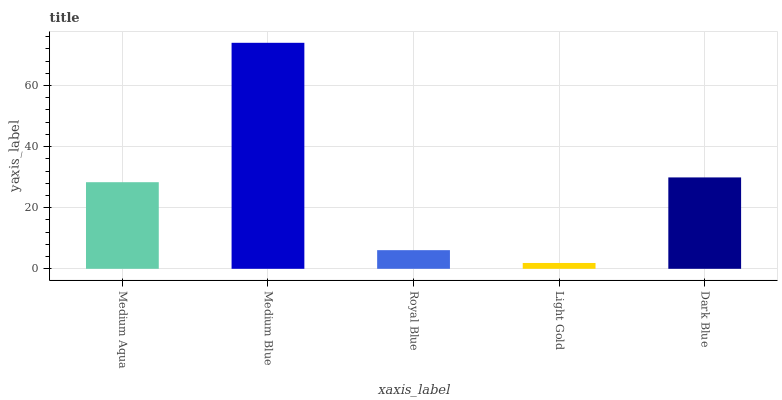Is Light Gold the minimum?
Answer yes or no. Yes. Is Medium Blue the maximum?
Answer yes or no. Yes. Is Royal Blue the minimum?
Answer yes or no. No. Is Royal Blue the maximum?
Answer yes or no. No. Is Medium Blue greater than Royal Blue?
Answer yes or no. Yes. Is Royal Blue less than Medium Blue?
Answer yes or no. Yes. Is Royal Blue greater than Medium Blue?
Answer yes or no. No. Is Medium Blue less than Royal Blue?
Answer yes or no. No. Is Medium Aqua the high median?
Answer yes or no. Yes. Is Medium Aqua the low median?
Answer yes or no. Yes. Is Light Gold the high median?
Answer yes or no. No. Is Medium Blue the low median?
Answer yes or no. No. 